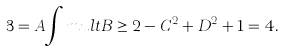<formula> <loc_0><loc_0><loc_500><loc_500>3 = A { \int m u l t } B \geq 2 - C ^ { 2 } + D ^ { 2 } + 1 = 4 .</formula> 